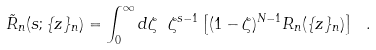Convert formula to latex. <formula><loc_0><loc_0><loc_500><loc_500>\tilde { R } _ { n } ( s ; \{ z \} _ { n } ) = \int _ { 0 } ^ { \infty } d \zeta \ \zeta ^ { s - 1 } \left [ ( 1 - \zeta ) ^ { N - 1 } R _ { n } ( \{ z \} _ { n } ) \right ] \ .</formula> 